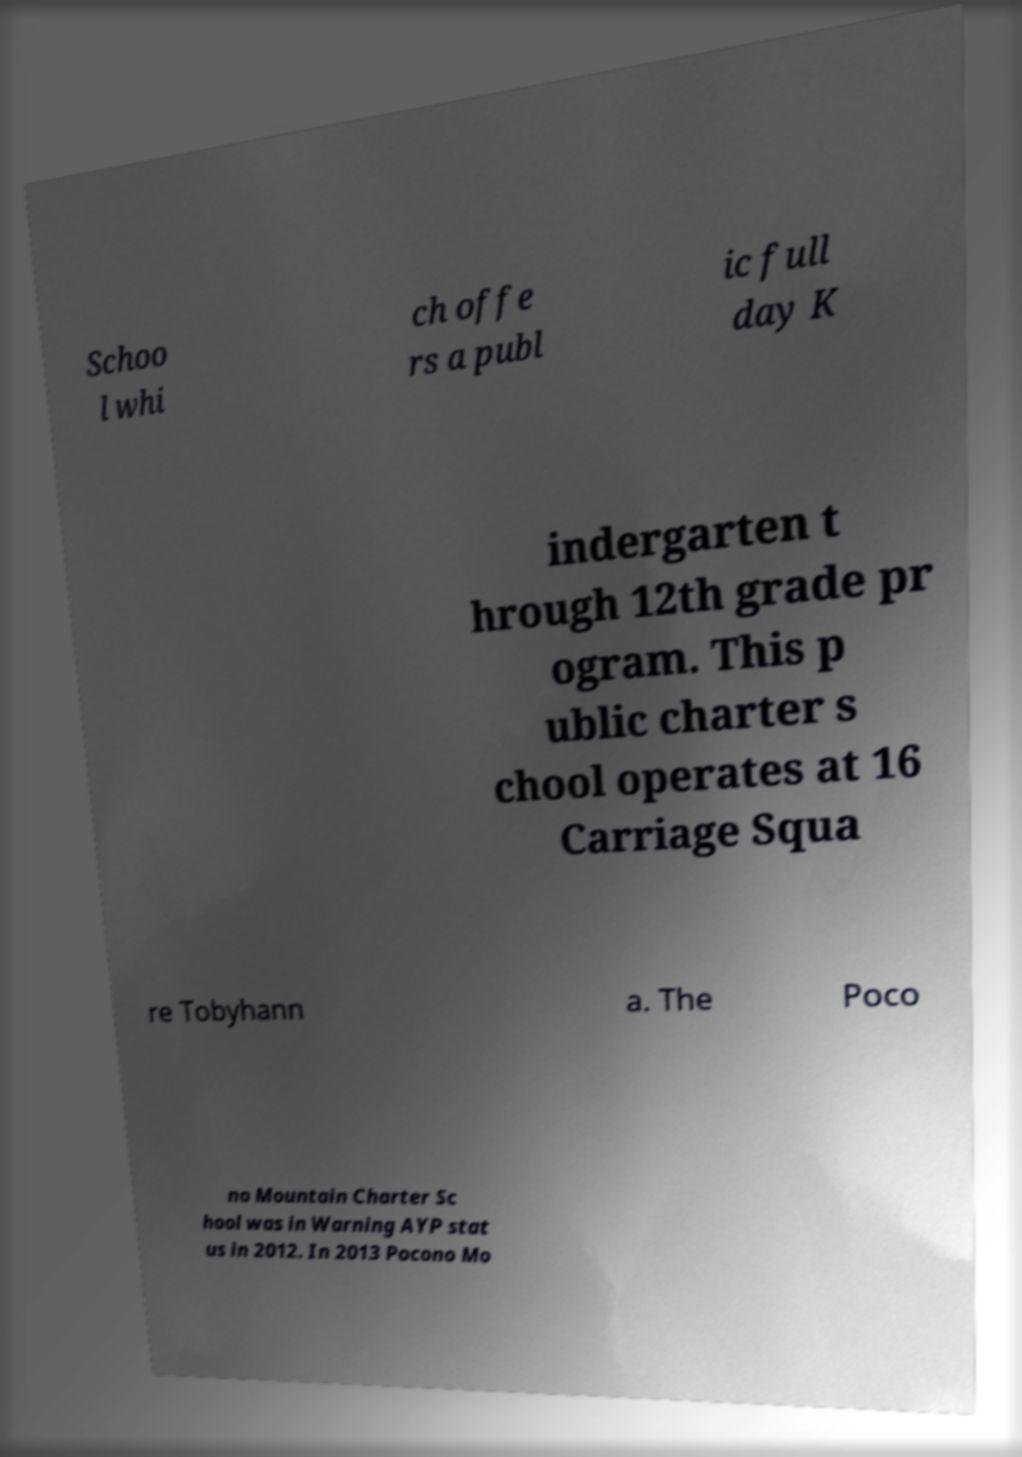Can you read and provide the text displayed in the image?This photo seems to have some interesting text. Can you extract and type it out for me? Schoo l whi ch offe rs a publ ic full day K indergarten t hrough 12th grade pr ogram. This p ublic charter s chool operates at 16 Carriage Squa re Tobyhann a. The Poco no Mountain Charter Sc hool was in Warning AYP stat us in 2012. In 2013 Pocono Mo 